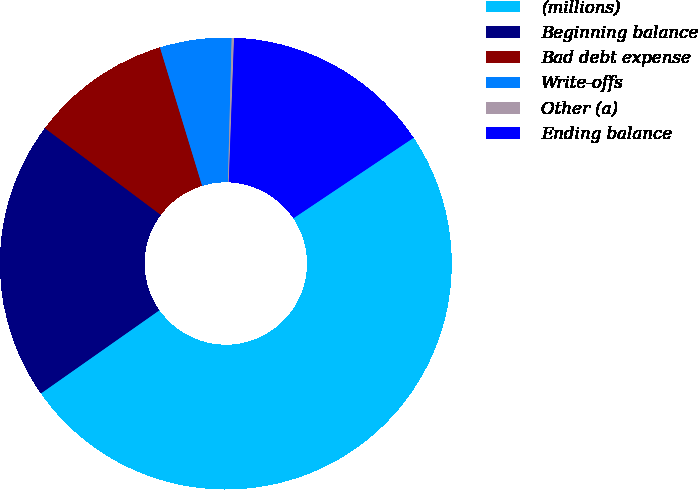<chart> <loc_0><loc_0><loc_500><loc_500><pie_chart><fcel>(millions)<fcel>Beginning balance<fcel>Bad debt expense<fcel>Write-offs<fcel>Other (a)<fcel>Ending balance<nl><fcel>49.65%<fcel>19.97%<fcel>10.07%<fcel>5.12%<fcel>0.17%<fcel>15.02%<nl></chart> 